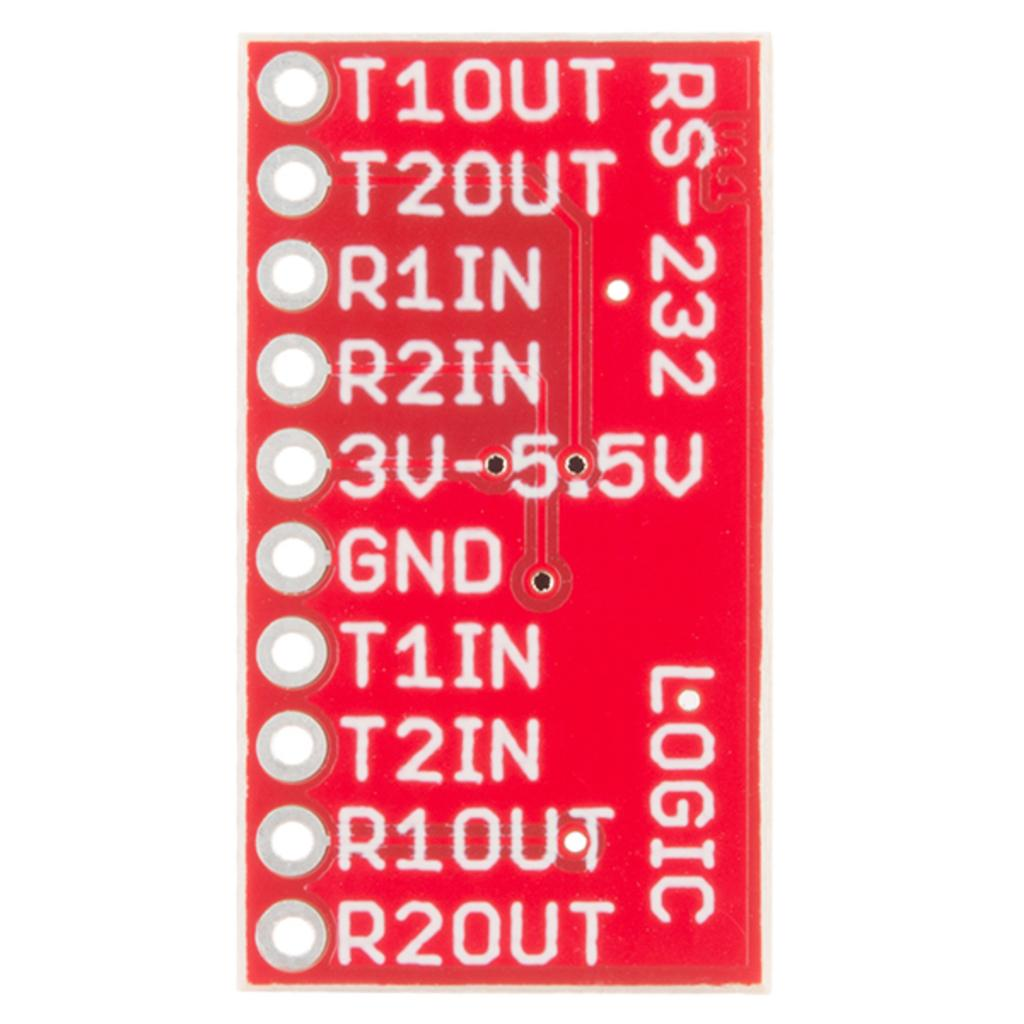<image>
Give a short and clear explanation of the subsequent image. a red item with numbers on it including T1IN 